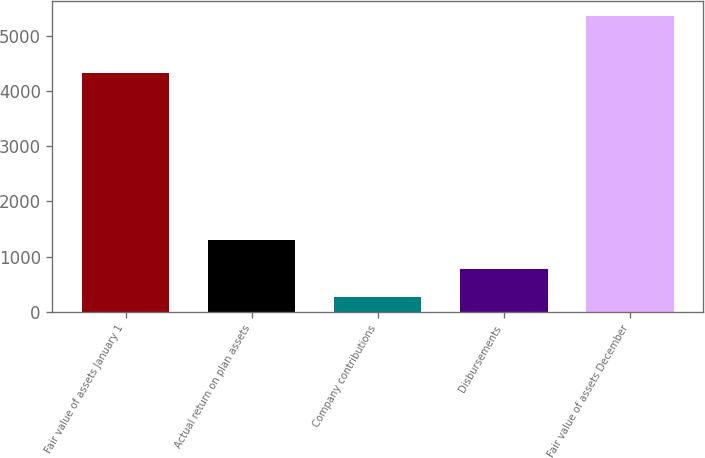Convert chart to OTSL. <chart><loc_0><loc_0><loc_500><loc_500><bar_chart><fcel>Fair value of assets January 1<fcel>Actual return on plan assets<fcel>Company contributions<fcel>Disbursements<fcel>Fair value of assets December<nl><fcel>4319<fcel>1291.4<fcel>275<fcel>783.2<fcel>5357<nl></chart> 